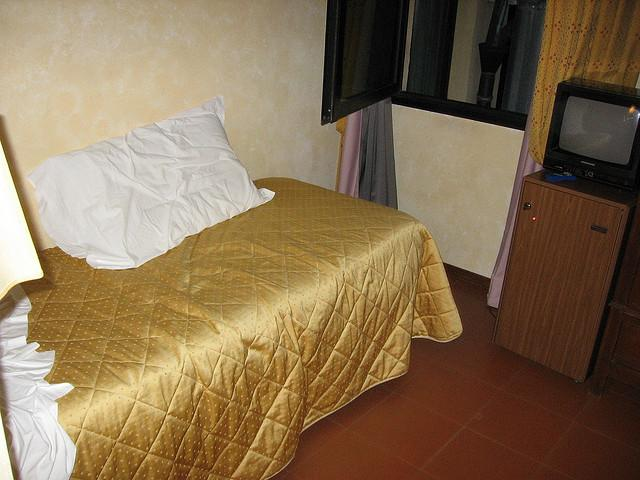What color is the sheet covering the small twin bed on the corner of the room?

Choices:
A) green
B) blue
C) pink
D) yellow yellow 